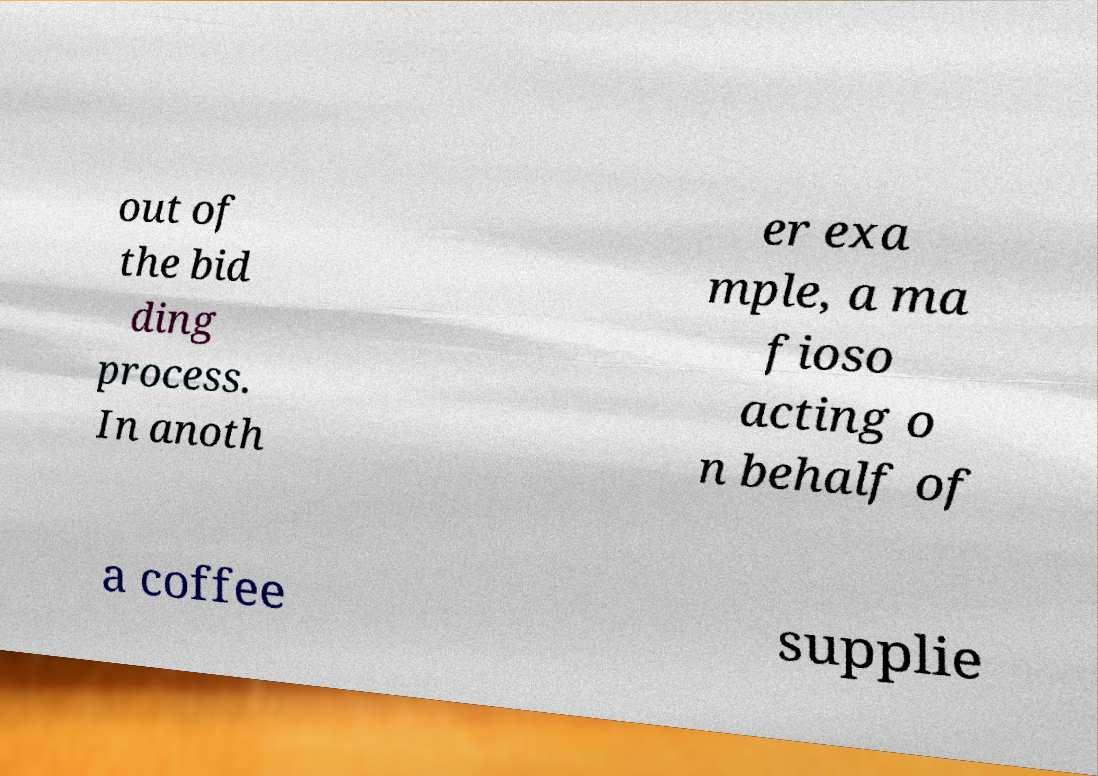Can you read and provide the text displayed in the image?This photo seems to have some interesting text. Can you extract and type it out for me? out of the bid ding process. In anoth er exa mple, a ma fioso acting o n behalf of a coffee supplie 